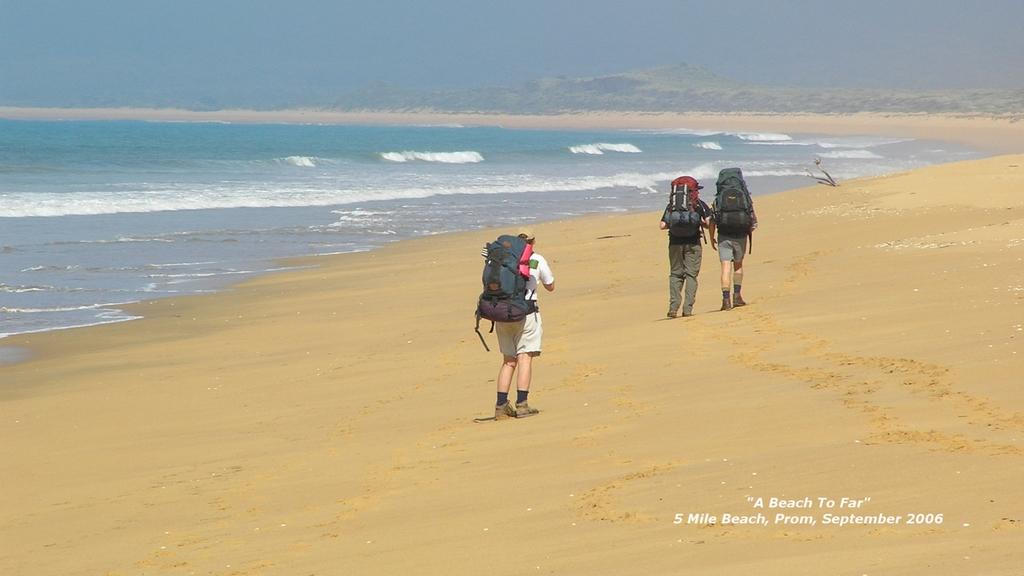How many people are in the image? There are three people in the image. What are the people wearing? The people are wearing bags. What type of terrain are the people walking on? The people are walking on the beach sand. What can be seen in the background of the image? There are mountains in the background of the image. What type of collar can be seen on the hen in the image? There is no hen present in the image, and therefore no collar can be seen. 